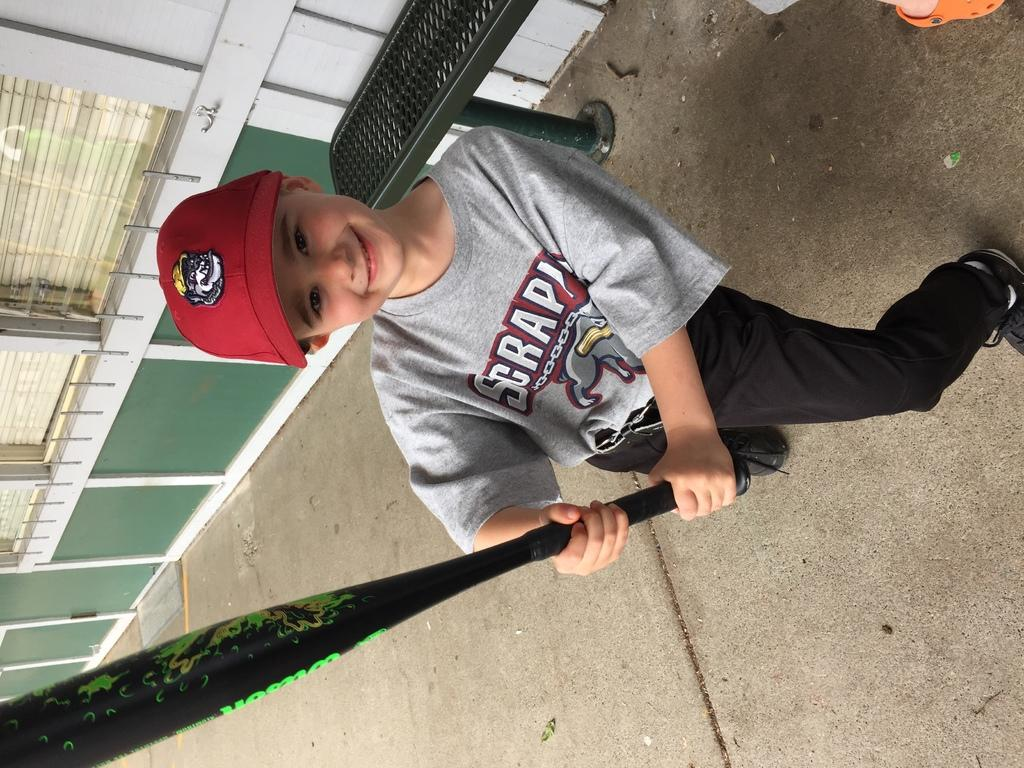What is the main subject of the image? The main subject of the image is a little cute boy. What is the boy holding in the image? The boy is holding a baseball bat. What type of clothing is the boy wearing on his upper body? The boy is wearing a t-shirt. What type of clothing is the boy wearing on his lower body? The boy is wearing trousers. What type of headwear is the boy wearing in the image? The boy is wearing a red color cap. What type of art is the boy creating while sleeping in the image? There is no indication in the image that the boy is sleeping or creating any art. 